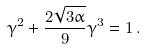<formula> <loc_0><loc_0><loc_500><loc_500>\gamma ^ { 2 } + \frac { 2 \sqrt { 3 \alpha } } { 9 } \gamma ^ { 3 } = 1 \, .</formula> 